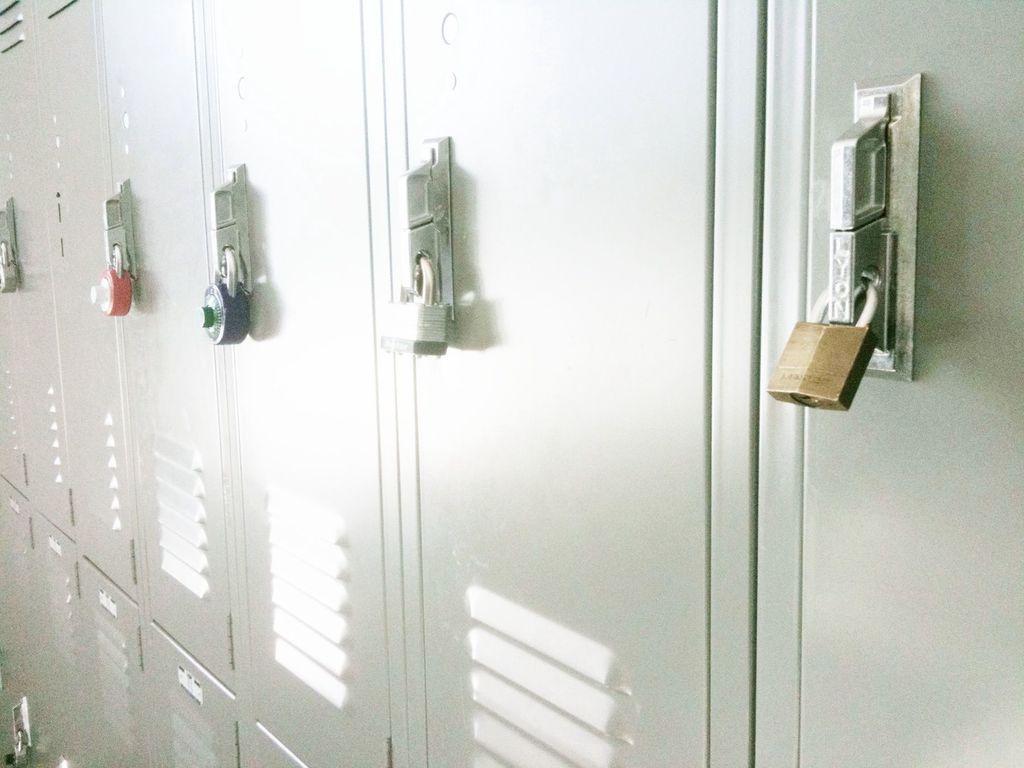Please provide a concise description of this image. In this image I can see some lockers which are in ash color. And I can see the locks to the lockers. These blocks are in red, blue, white and brown color. 